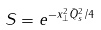Convert formula to latex. <formula><loc_0><loc_0><loc_500><loc_500>S = e ^ { - x _ { \perp } ^ { 2 } { \bar { Q } } _ { s } ^ { 2 } / 4 }</formula> 